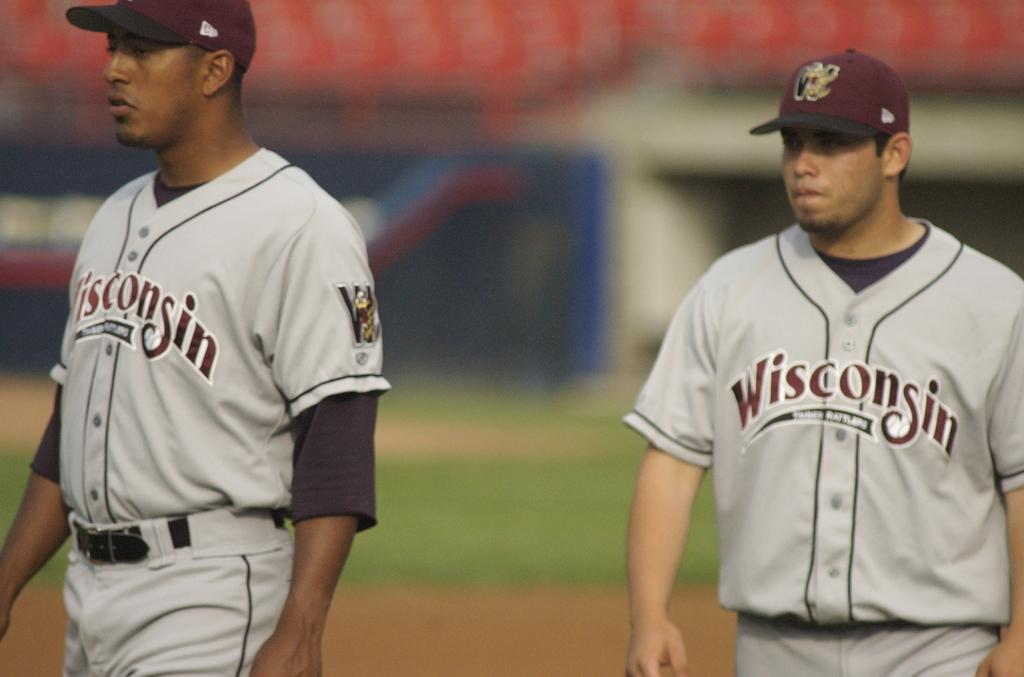<image>
Share a concise interpretation of the image provided. A couple of Wisconsin players in gray uniforms display serious expressions. 